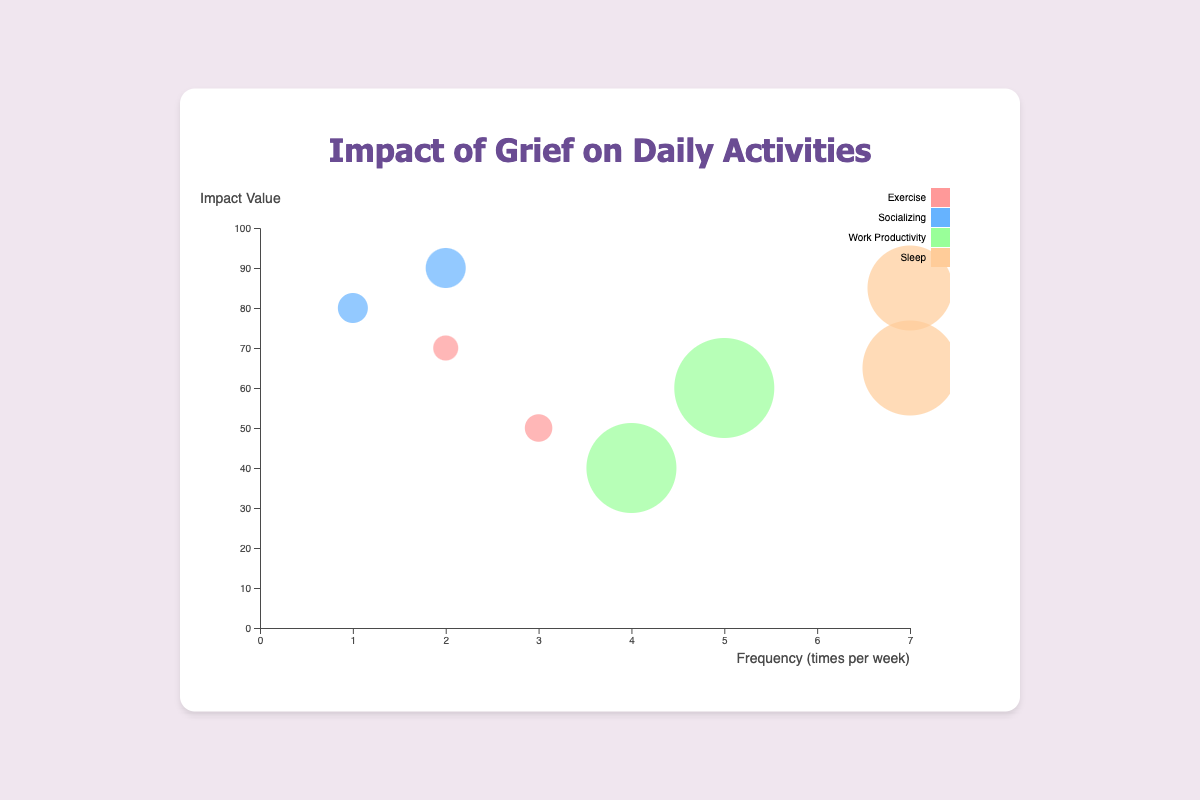What is the title of the chart? The title is clearly displayed at the top of the chart in a larger font size. By looking at this, we can read the exact title.
Answer: Impact of Grief on Daily Activities How many different categories are represented in the chart? There are four distinct categories denoted by different colors in the chart's legend: Exercise, Socializing, Work Productivity, and Sleep.
Answer: Four What color represents the "Socializing" category? By referring to the legend on the right side of the chart, the color corresponding to "Socializing" is found.
Answer: Blue What is the range of the X-axis? Observing the X-axis shows the frequency with ticks indicating values from 0 to 7.
Answer: 0 to 7 Among the activities, which one has the highest impact value? The "Socializing" category has one data point at an impact value of 90, which is the highest value among all points.
Answer: Socializing Which activity has an instance with the highest duration? By comparing the sizes of the circles, the largest bubble represents a duration of 480 minutes found in the "Work Productivity" category.
Answer: Work Productivity Compare the frequency of "Exercise" vs. "Sleep" categories. Which one appears more frequently? Looking at the X-axis positions, "Sleep" data points are at frequency 7, and "Exercise" data points are at frequencies 2 and 3. Hence, "Sleep" is more frequent.
Answer: Sleep Which data point has the smallest impact value? By examining the position along the Y-axis, the lowest value is 40, which corresponds to a "Work Productivity" point.
Answer: Work Productivity How does the impact value of "Exercise" with the lowest frequency compare to the highest value of "Socializing"? The lowest frequency exercise has an impact value of 70, whereas the highest socializing value is 90, thus showing socializing has a higher impact.
Answer: Socializing has a higher impact What's the average impact value of data points in the "Sleep" category? The two impact values in "Sleep" category are 85 and 65. Adding these gives 150, and dividing by 2 (the number of points) results in an average impact value of 75.
Answer: 75 